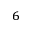Convert formula to latex. <formula><loc_0><loc_0><loc_500><loc_500>_ { 6 }</formula> 